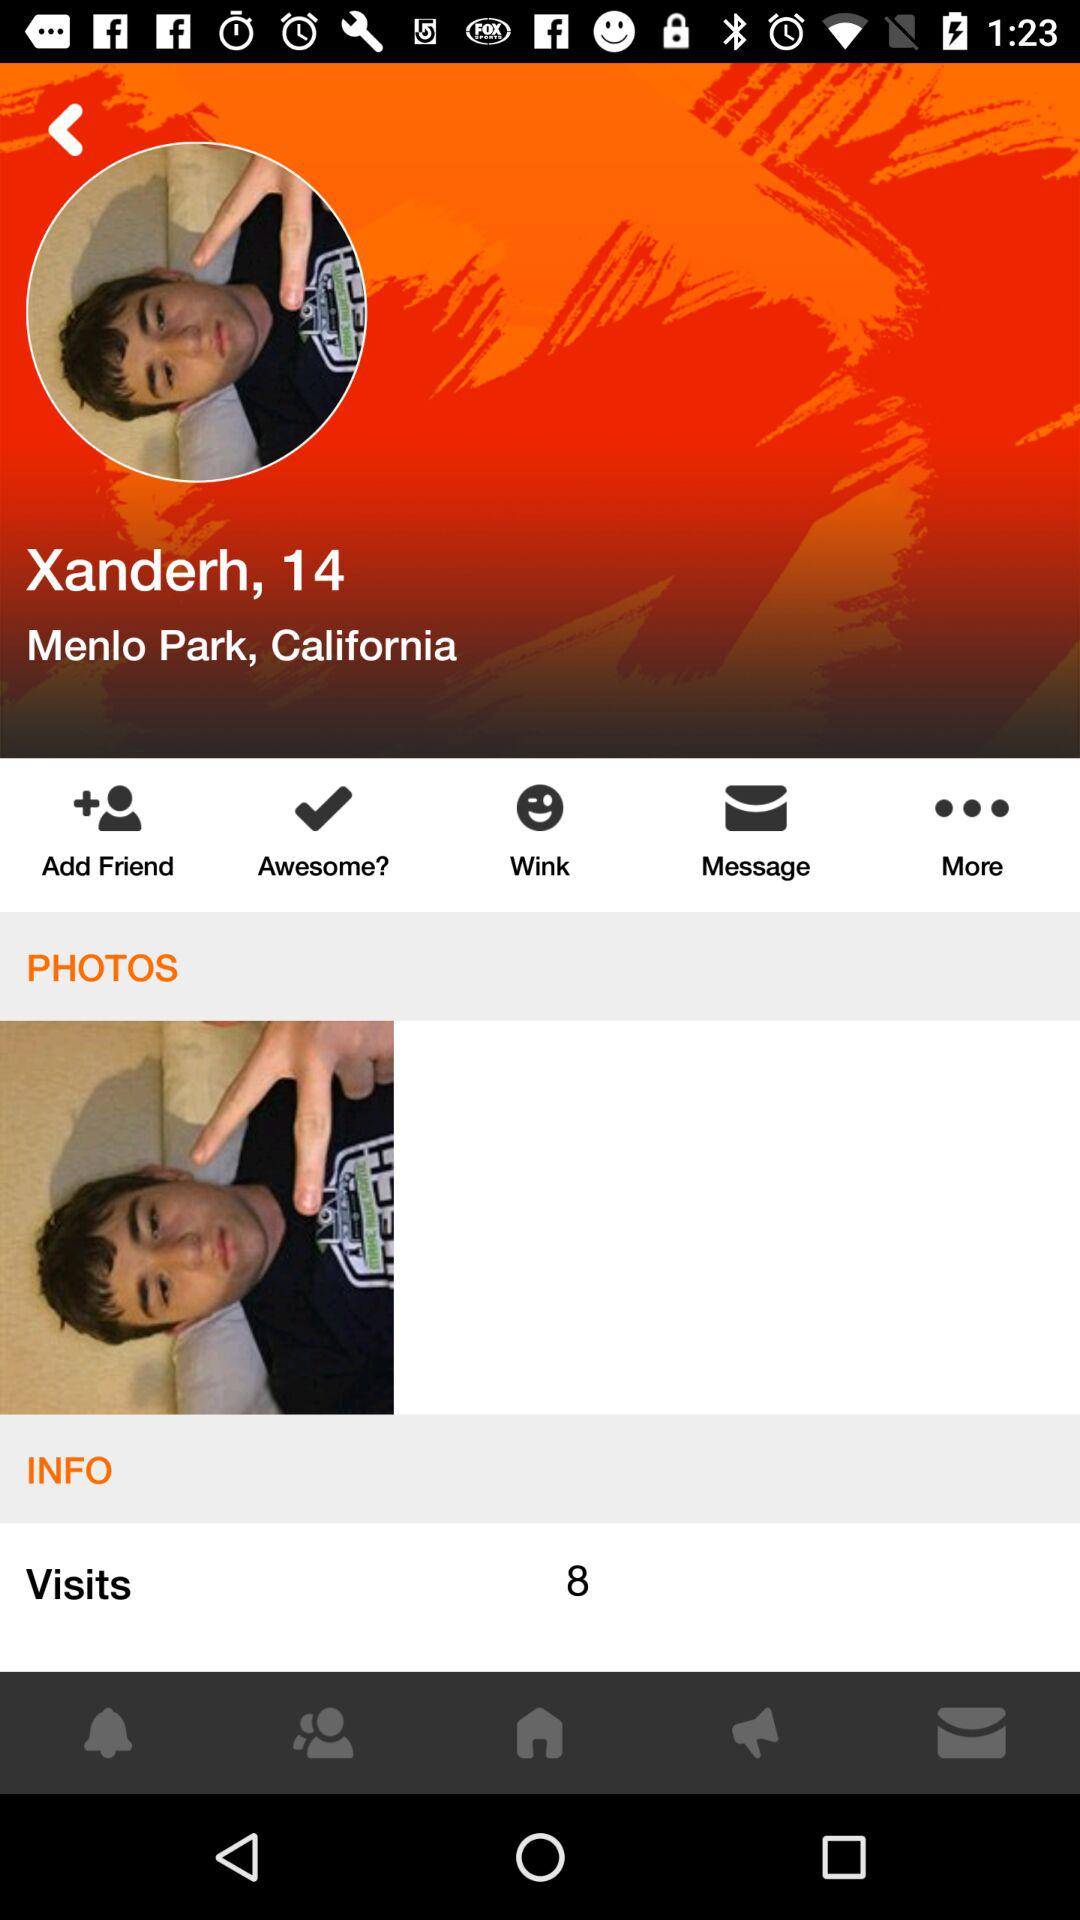What is the name of the user? The name of the user is Xanderh. 